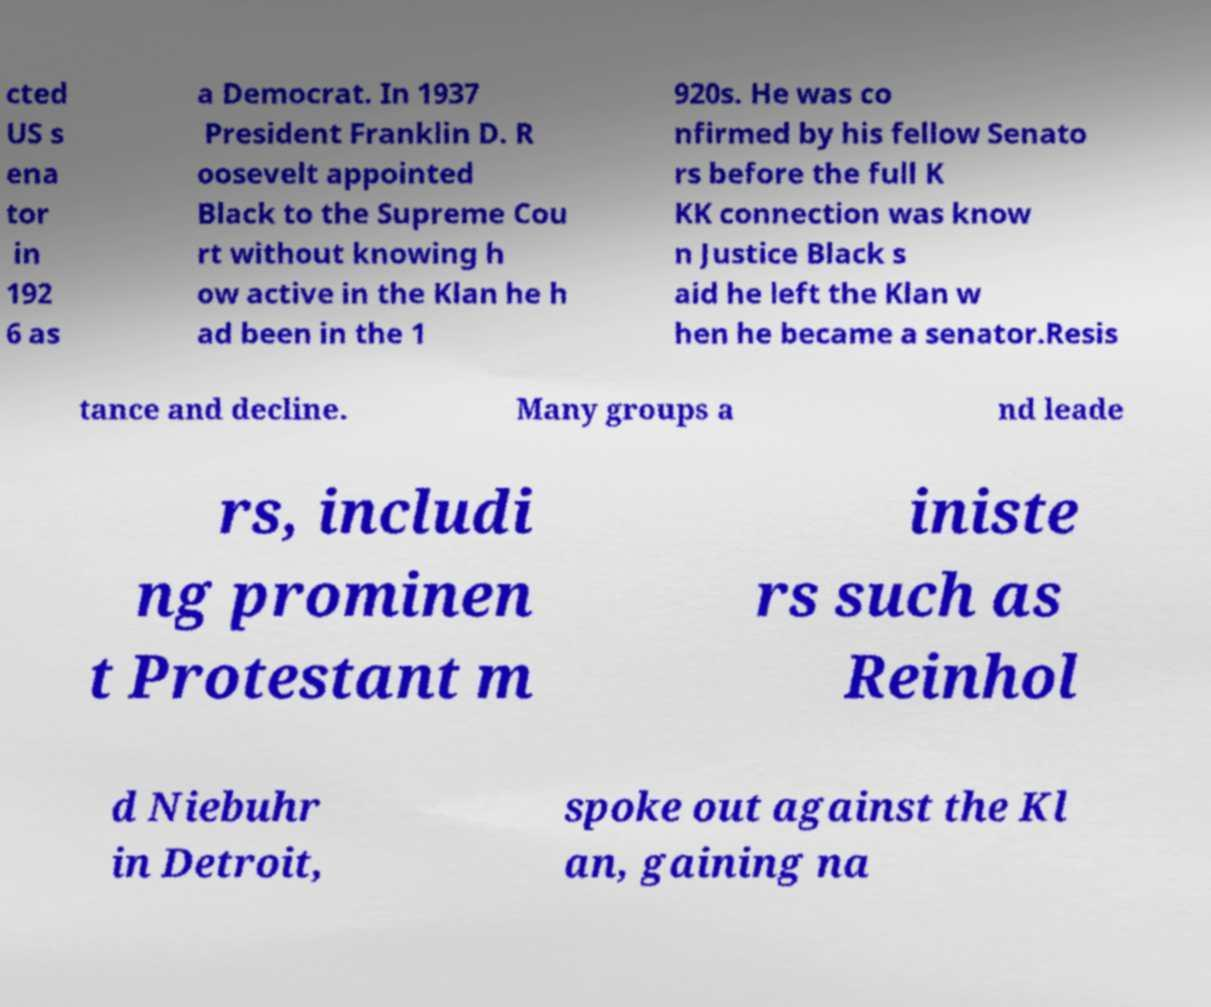Can you read and provide the text displayed in the image?This photo seems to have some interesting text. Can you extract and type it out for me? cted US s ena tor in 192 6 as a Democrat. In 1937 President Franklin D. R oosevelt appointed Black to the Supreme Cou rt without knowing h ow active in the Klan he h ad been in the 1 920s. He was co nfirmed by his fellow Senato rs before the full K KK connection was know n Justice Black s aid he left the Klan w hen he became a senator.Resis tance and decline. Many groups a nd leade rs, includi ng prominen t Protestant m iniste rs such as Reinhol d Niebuhr in Detroit, spoke out against the Kl an, gaining na 